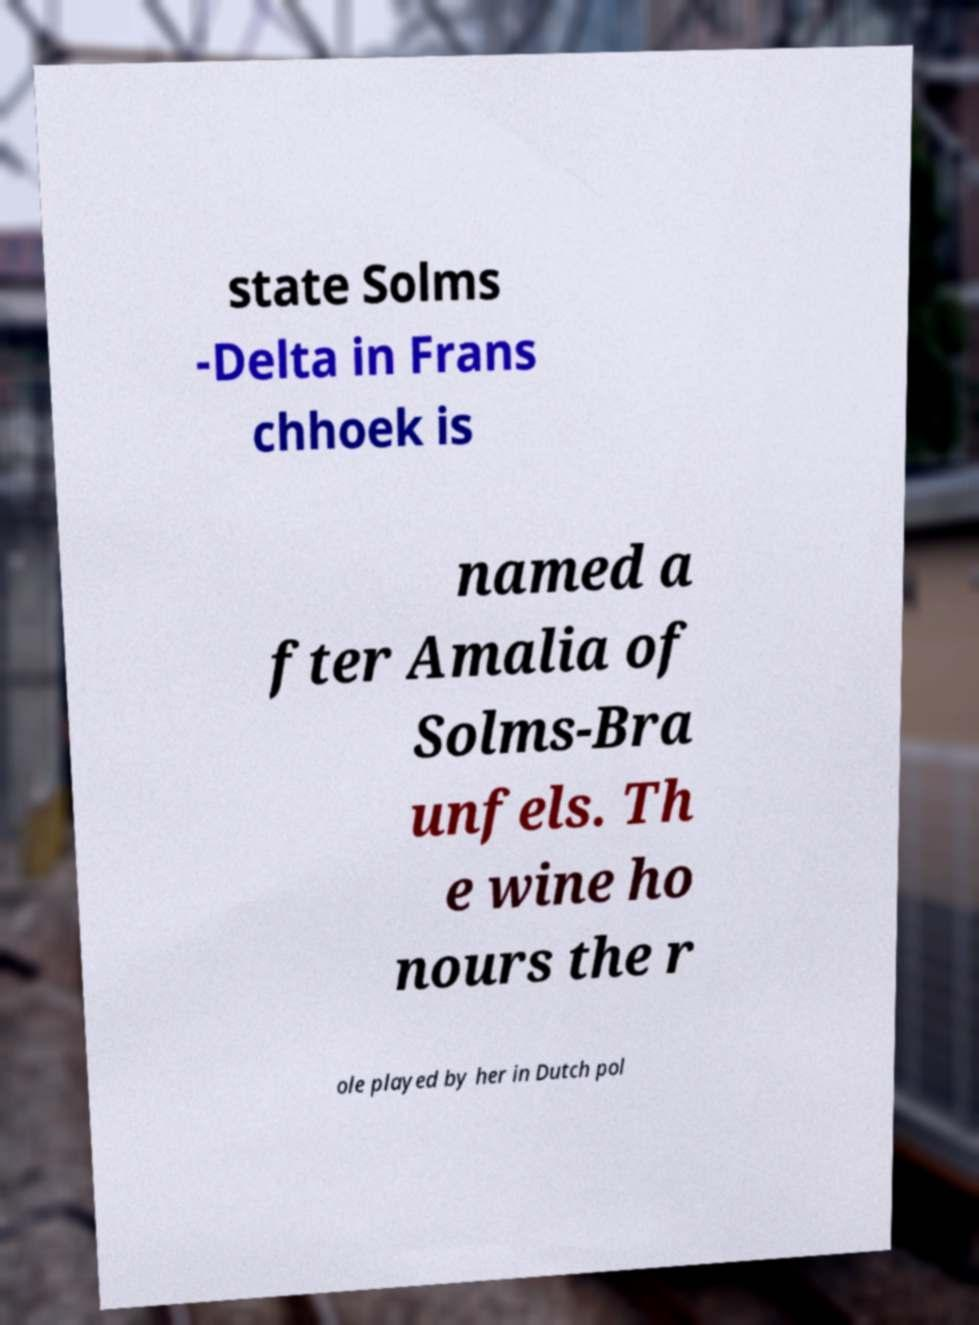Please identify and transcribe the text found in this image. state Solms -Delta in Frans chhoek is named a fter Amalia of Solms-Bra unfels. Th e wine ho nours the r ole played by her in Dutch pol 